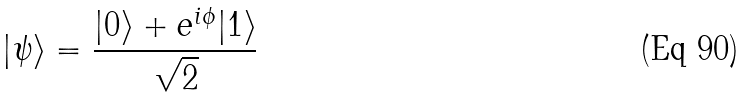<formula> <loc_0><loc_0><loc_500><loc_500>| \psi \rangle = \frac { | 0 \rangle + e ^ { i \phi } | 1 \rangle } { \sqrt { 2 } }</formula> 